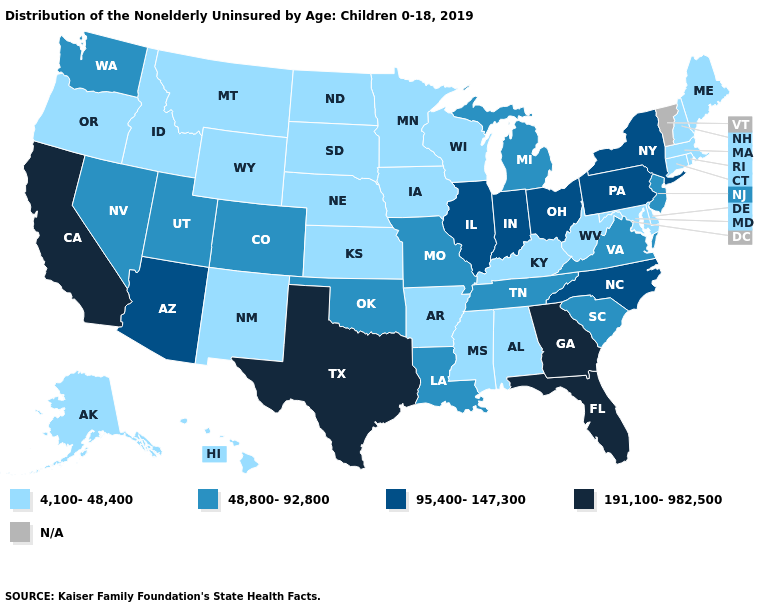Does the map have missing data?
Short answer required. Yes. What is the value of Michigan?
Be succinct. 48,800-92,800. What is the highest value in the MidWest ?
Give a very brief answer. 95,400-147,300. Name the states that have a value in the range 95,400-147,300?
Answer briefly. Arizona, Illinois, Indiana, New York, North Carolina, Ohio, Pennsylvania. What is the value of Ohio?
Be succinct. 95,400-147,300. Among the states that border Maine , which have the highest value?
Short answer required. New Hampshire. What is the highest value in states that border Washington?
Give a very brief answer. 4,100-48,400. Does the first symbol in the legend represent the smallest category?
Concise answer only. Yes. Does the map have missing data?
Short answer required. Yes. What is the value of Illinois?
Concise answer only. 95,400-147,300. Does the map have missing data?
Keep it brief. Yes. What is the highest value in the USA?
Keep it brief. 191,100-982,500. Which states have the highest value in the USA?
Give a very brief answer. California, Florida, Georgia, Texas. Among the states that border New York , which have the lowest value?
Short answer required. Connecticut, Massachusetts. 